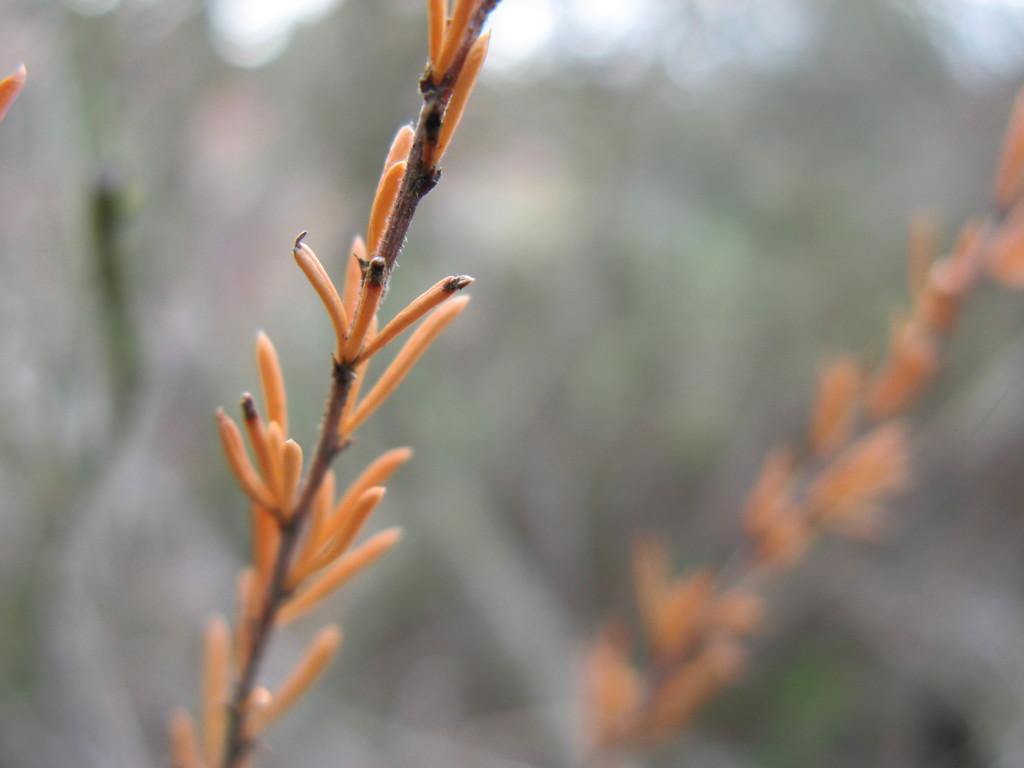How would you summarize this image in a sentence or two? In this image I can see few flowers which are orange and black in color to the plants. I can see the blurry background. 